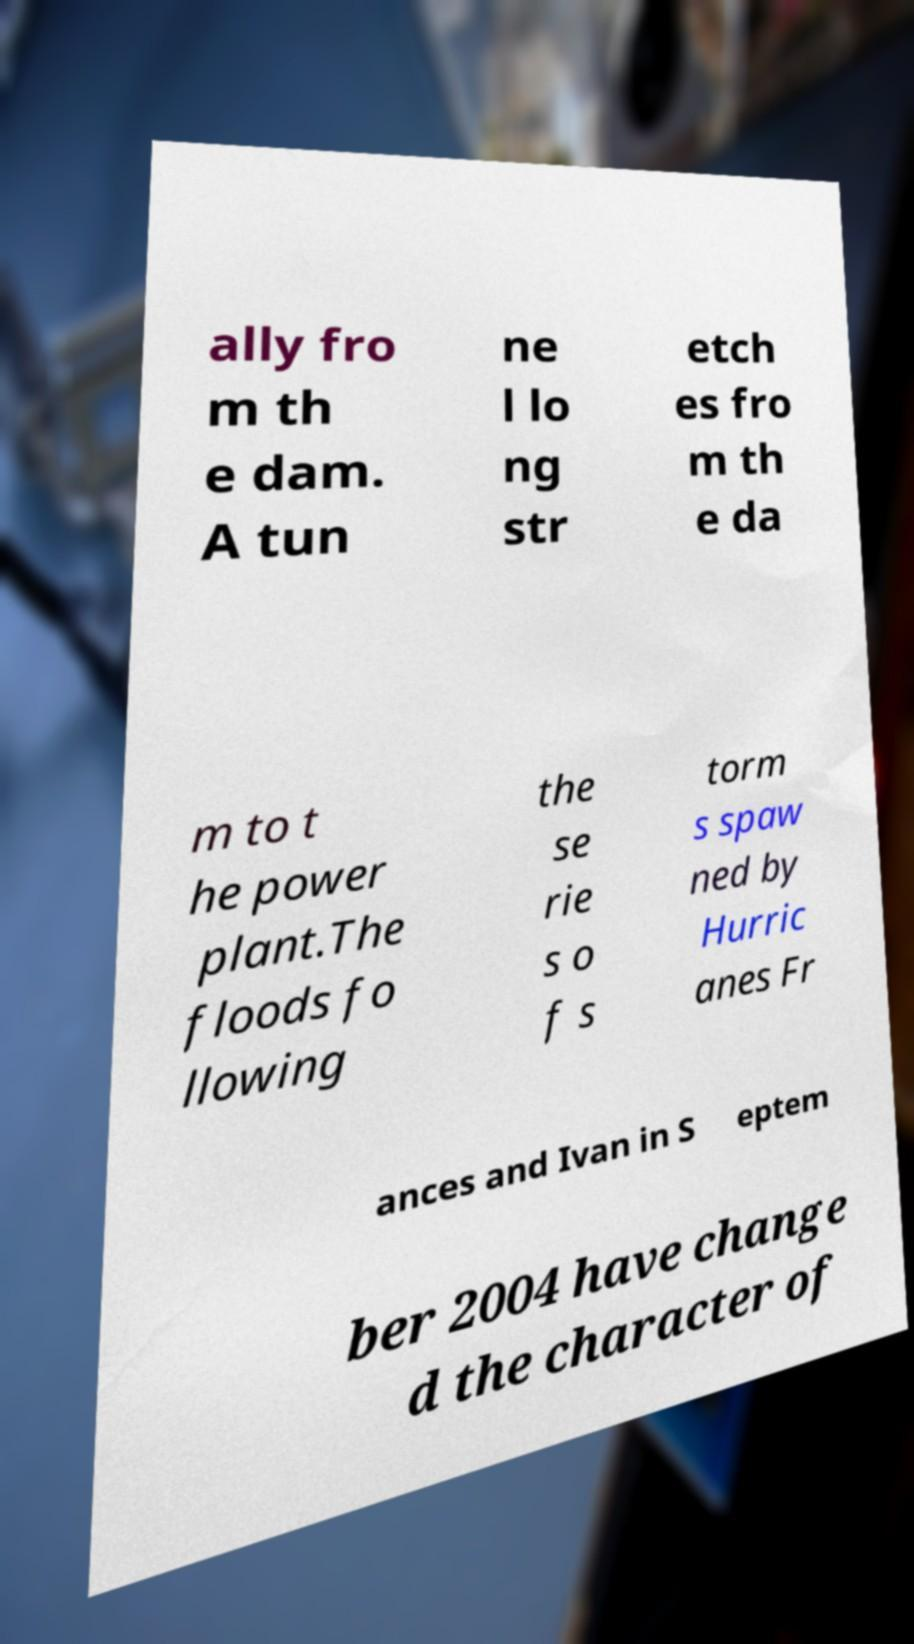For documentation purposes, I need the text within this image transcribed. Could you provide that? ally fro m th e dam. A tun ne l lo ng str etch es fro m th e da m to t he power plant.The floods fo llowing the se rie s o f s torm s spaw ned by Hurric anes Fr ances and Ivan in S eptem ber 2004 have change d the character of 